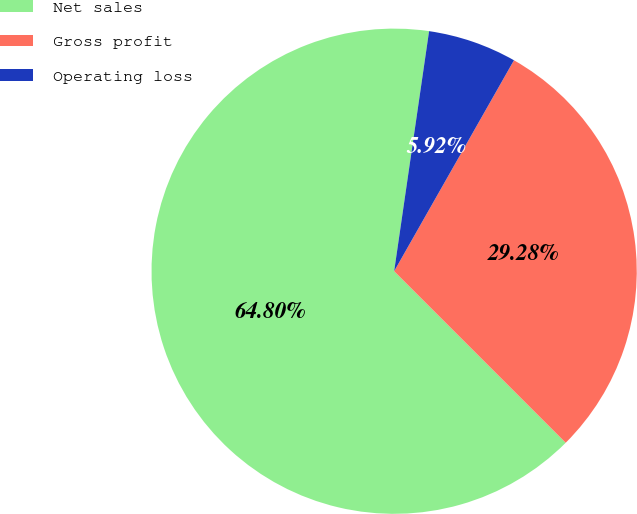<chart> <loc_0><loc_0><loc_500><loc_500><pie_chart><fcel>Net sales<fcel>Gross profit<fcel>Operating loss<nl><fcel>64.8%<fcel>29.28%<fcel>5.92%<nl></chart> 